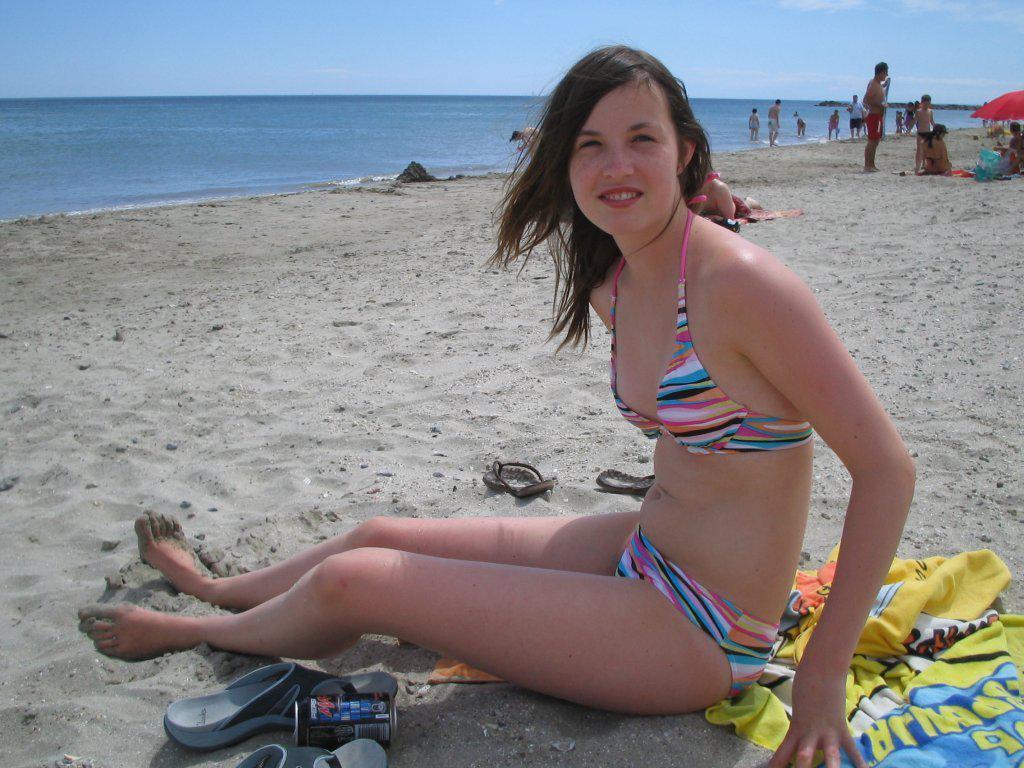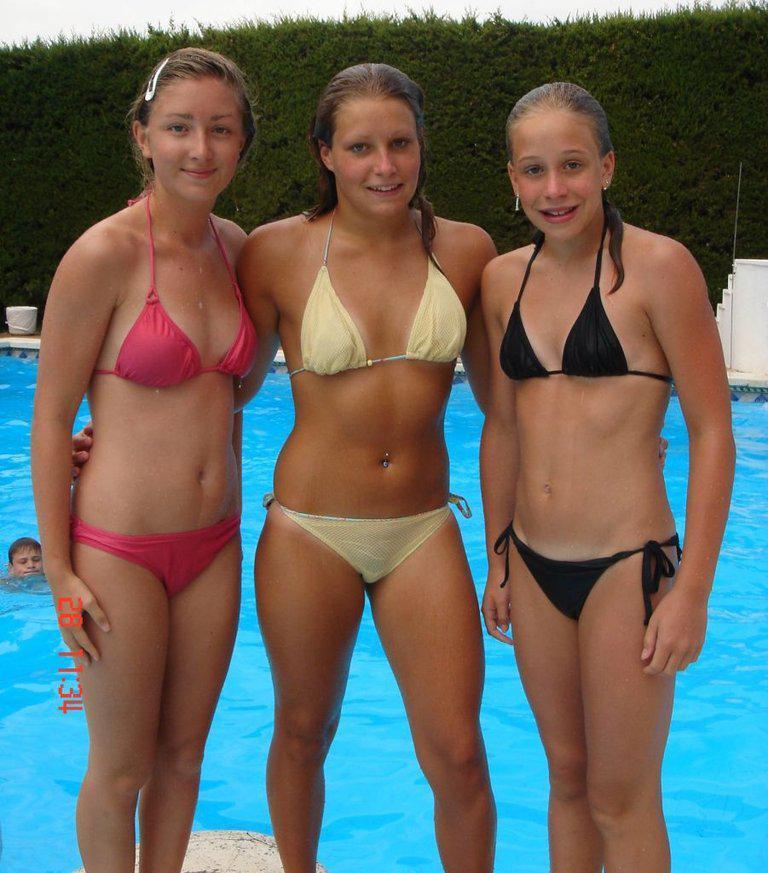The first image is the image on the left, the second image is the image on the right. Analyze the images presented: Is the assertion "There are four girls wearing swimsuits at the beach in one of the images." valid? Answer yes or no. No. The first image is the image on the left, the second image is the image on the right. Assess this claim about the two images: "There are seven girls.". Correct or not? Answer yes or no. No. 